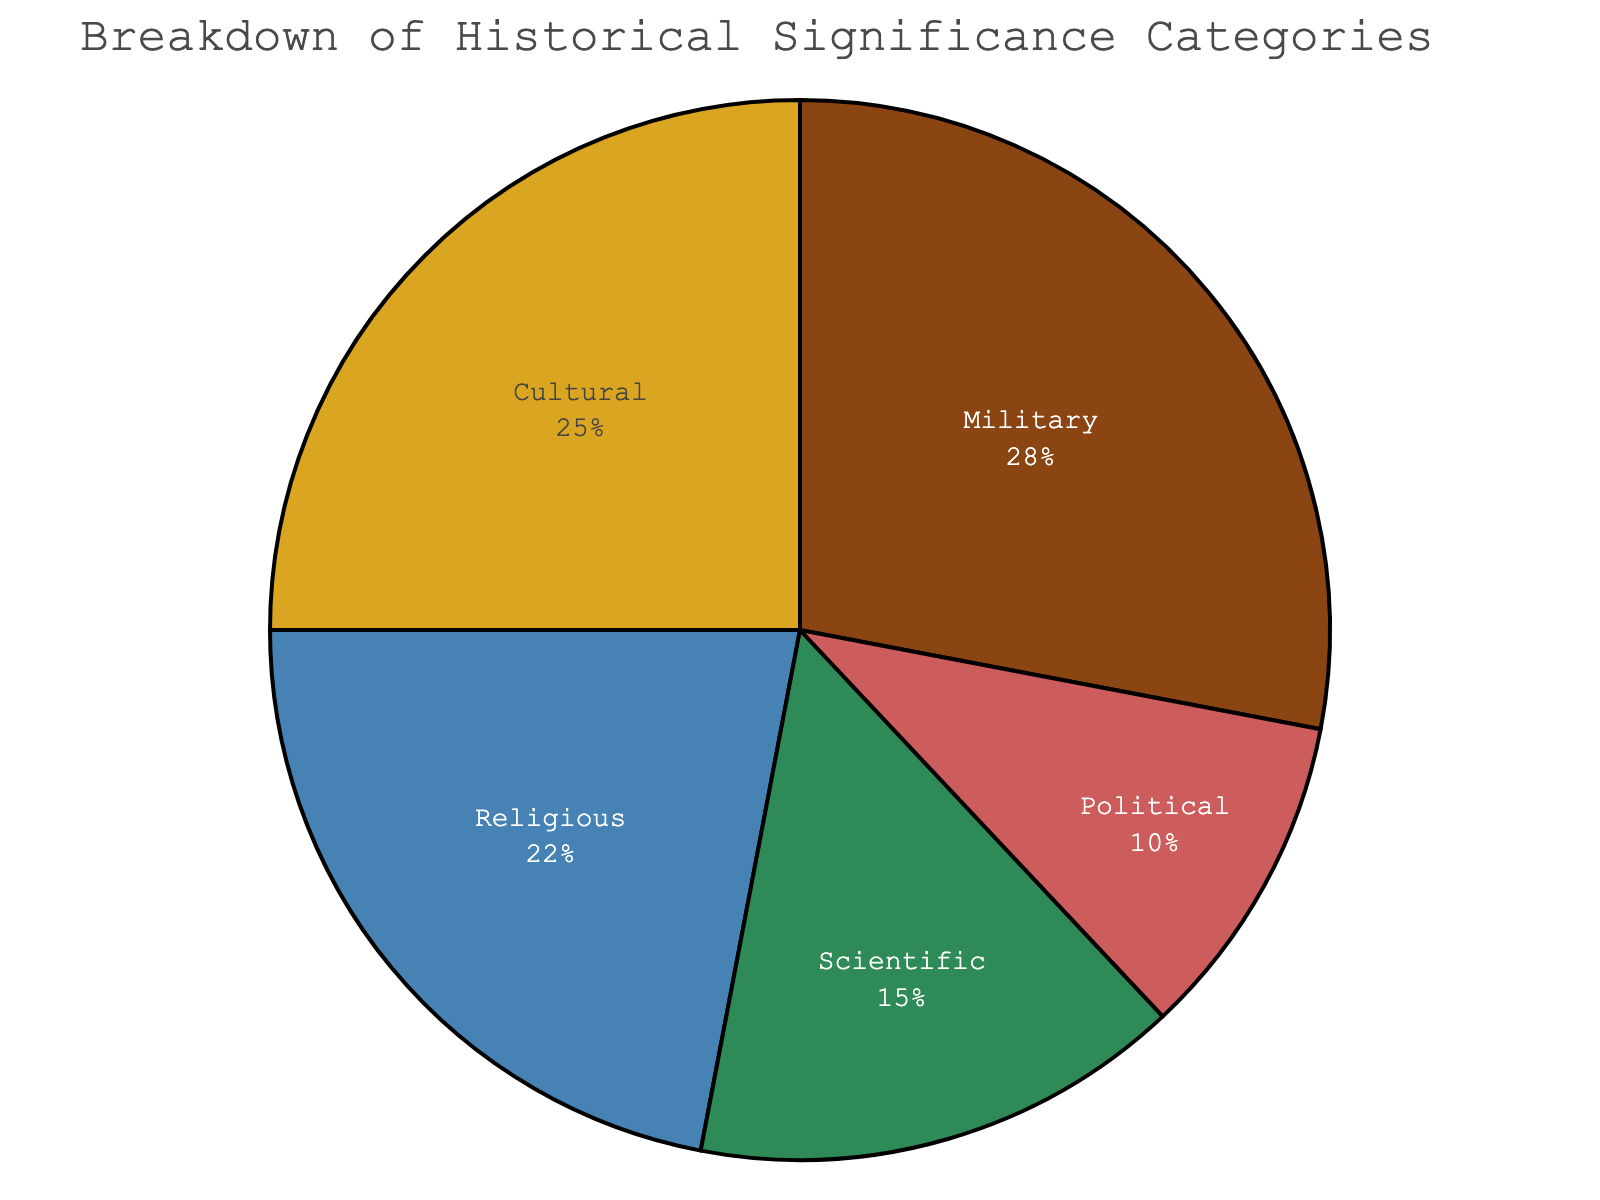What is the category with the highest percentage? By observing the pie chart, you can see that the largest segment corresponds to the Military category. The percentage label inside this section reads 28%, indicating it’s the highest.
Answer: Military Which category accounts for 15% of the significance? The percentage of each category is labeled inside their respective segments. The segment labeled with 15% corresponds to the Scientific category.
Answer: Scientific How do the percentages of Military and Cultural significance compare? The Military segment is labeled 28% and the Cultural segment is labeled 25%. Therefore, Military has a higher percentage than Cultural.
Answer: Military is higher What is the combined percentage of Religious and Political significance? The Religious segment is labeled 22%, and the Political segment is labeled 10%. Adding these two percentages together (22 + 10) gives a total of 32%.
Answer: 32% If you combine the significance percentages of Cultural, Religious, and Political, how much more is left compared to 100%? Adding the percentages of Cultural (25%), Religious (22%), and Political (10%) gives a total of 57%. Subtracting this from 100% (100 - 57) leaves 43% unaccounted for.
Answer: 43% Which category has the lowest significance, and what percentage is it? The smallest segment by visual inspection corresponds to the Political category, which is labeled with 10%.
Answer: Political with 10% What is the difference in percentage between Scientific and Religious categories? The Scientific segment is labeled 15%, and the Religious segment is labeled 22%. Subtracting the Scientific percentage from the Religious percentage (22 - 15) gives a difference of 7%.
Answer: 7% What is the percentage contribution of the top two categories combined? The top two categories are Military (28%) and Cultural (25%). Adding these together (28 + 25) gives a total of 53%.
Answer: 53% Identify the category that uses a blue color in the pie chart and state its percentage. By visual inspection, the segment colored blue corresponds to the Scientific category, which is labeled with a percentage of 15%.
Answer: Scientific with 15% How much higher is the significance of Military compared to Political, and what is their ratio? The Military category is 28%, and the Political category is 10%. The difference is 18% (28 - 10). The ratio of Military to Political is 28:10, which simplifies to 2.8:1.
Answer: Difference is 18%, ratio is 2.8:1 